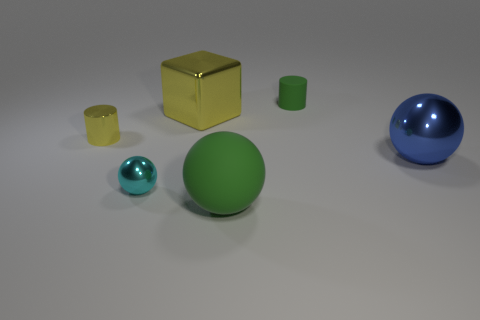There is a tiny cyan thing that is the same shape as the blue metal thing; what material is it?
Your answer should be compact. Metal. What number of spheres are behind the big ball in front of the ball that is on the left side of the large metallic cube?
Offer a terse response. 2. Are there more green matte balls on the right side of the tiny yellow shiny cylinder than blocks that are in front of the blue metallic sphere?
Offer a terse response. Yes. What number of small brown things have the same shape as the small yellow thing?
Offer a terse response. 0. How many objects are big metal spheres that are behind the big green rubber sphere or green rubber objects that are in front of the metal cylinder?
Your response must be concise. 2. What is the material of the big thing that is behind the metallic object that is to the right of the tiny cylinder behind the small metallic cylinder?
Provide a succinct answer. Metal. There is a rubber thing that is to the right of the green sphere; does it have the same color as the large matte thing?
Offer a terse response. Yes. What is the material of the thing that is to the left of the big metal cube and right of the yellow cylinder?
Your answer should be very brief. Metal. Is there another ball that has the same size as the rubber sphere?
Give a very brief answer. Yes. How many yellow matte objects are there?
Your answer should be compact. 0. 